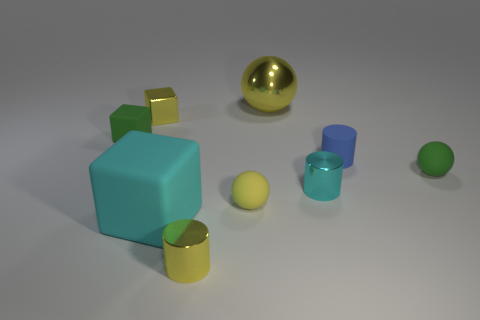What is the color of the cube that is in front of the sphere that is in front of the tiny green rubber object that is on the right side of the large yellow object?
Make the answer very short. Cyan. There is a tiny metal cube; are there any green objects on the left side of it?
Provide a short and direct response. Yes. What size is the metal cylinder that is the same color as the shiny sphere?
Your answer should be compact. Small. Are there any yellow objects made of the same material as the tiny cyan object?
Offer a very short reply. Yes. What color is the metallic sphere?
Provide a succinct answer. Yellow. There is a green matte thing right of the large yellow metal ball; is its shape the same as the small yellow rubber object?
Provide a succinct answer. Yes. The green object to the left of the tiny green rubber thing that is on the right side of the small cube that is on the right side of the small green block is what shape?
Your response must be concise. Cube. There is a small yellow thing in front of the cyan matte object; what is it made of?
Provide a succinct answer. Metal. There is a rubber block that is the same size as the blue rubber thing; what is its color?
Make the answer very short. Green. Does the cyan metallic object have the same size as the metallic cube?
Keep it short and to the point. Yes. 